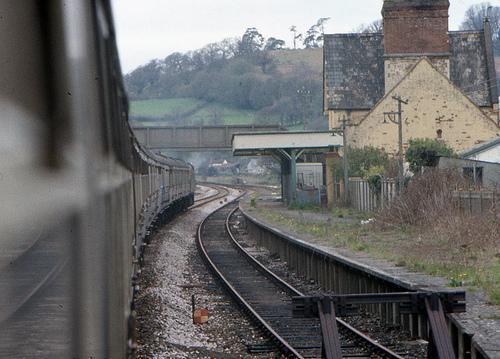How many tracks are there?
Give a very brief answer. 2. 